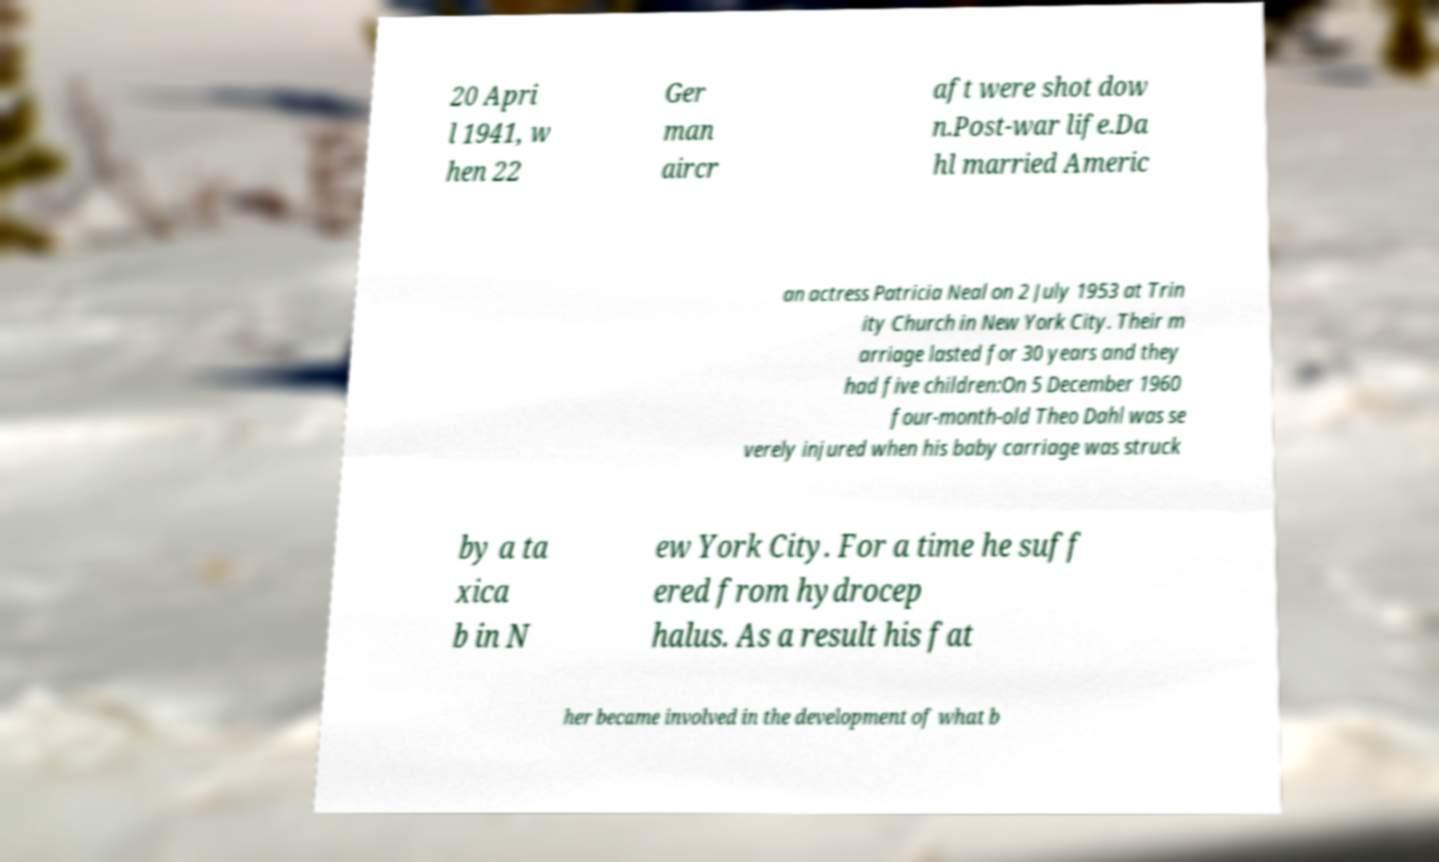What messages or text are displayed in this image? I need them in a readable, typed format. 20 Apri l 1941, w hen 22 Ger man aircr aft were shot dow n.Post-war life.Da hl married Americ an actress Patricia Neal on 2 July 1953 at Trin ity Church in New York City. Their m arriage lasted for 30 years and they had five children:On 5 December 1960 four-month-old Theo Dahl was se verely injured when his baby carriage was struck by a ta xica b in N ew York City. For a time he suff ered from hydrocep halus. As a result his fat her became involved in the development of what b 